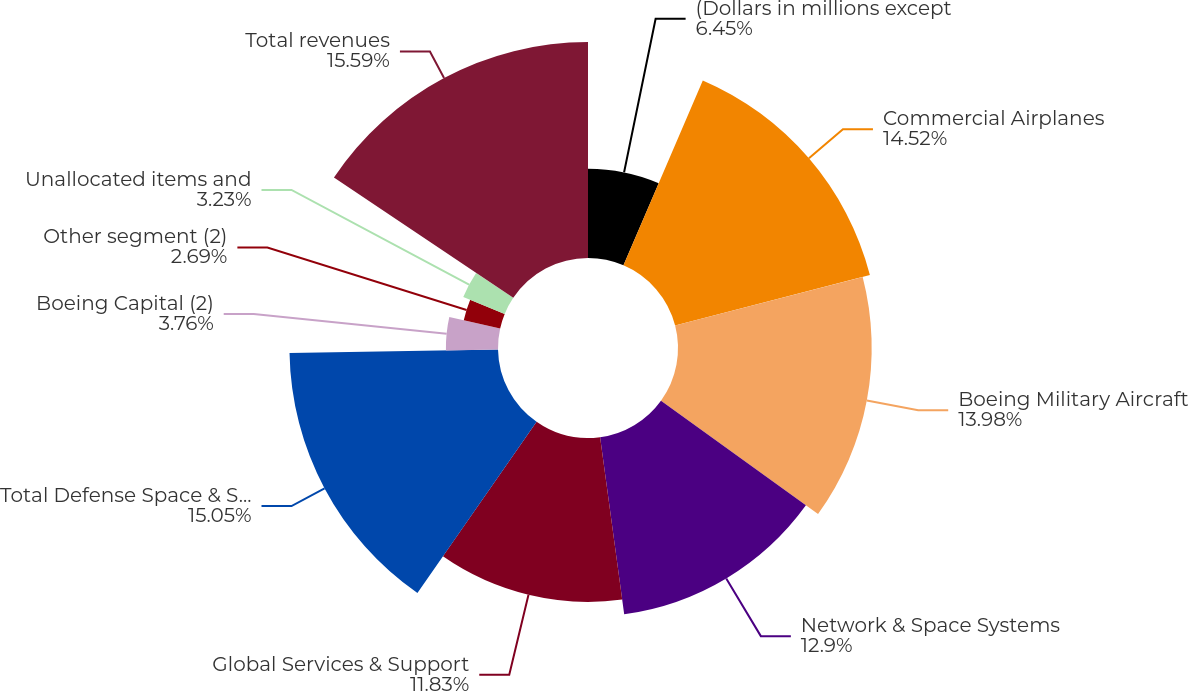Convert chart. <chart><loc_0><loc_0><loc_500><loc_500><pie_chart><fcel>(Dollars in millions except<fcel>Commercial Airplanes<fcel>Boeing Military Aircraft<fcel>Network & Space Systems<fcel>Global Services & Support<fcel>Total Defense Space & Security<fcel>Boeing Capital (2)<fcel>Other segment (2)<fcel>Unallocated items and<fcel>Total revenues<nl><fcel>6.45%<fcel>14.52%<fcel>13.98%<fcel>12.9%<fcel>11.83%<fcel>15.05%<fcel>3.76%<fcel>2.69%<fcel>3.23%<fcel>15.59%<nl></chart> 